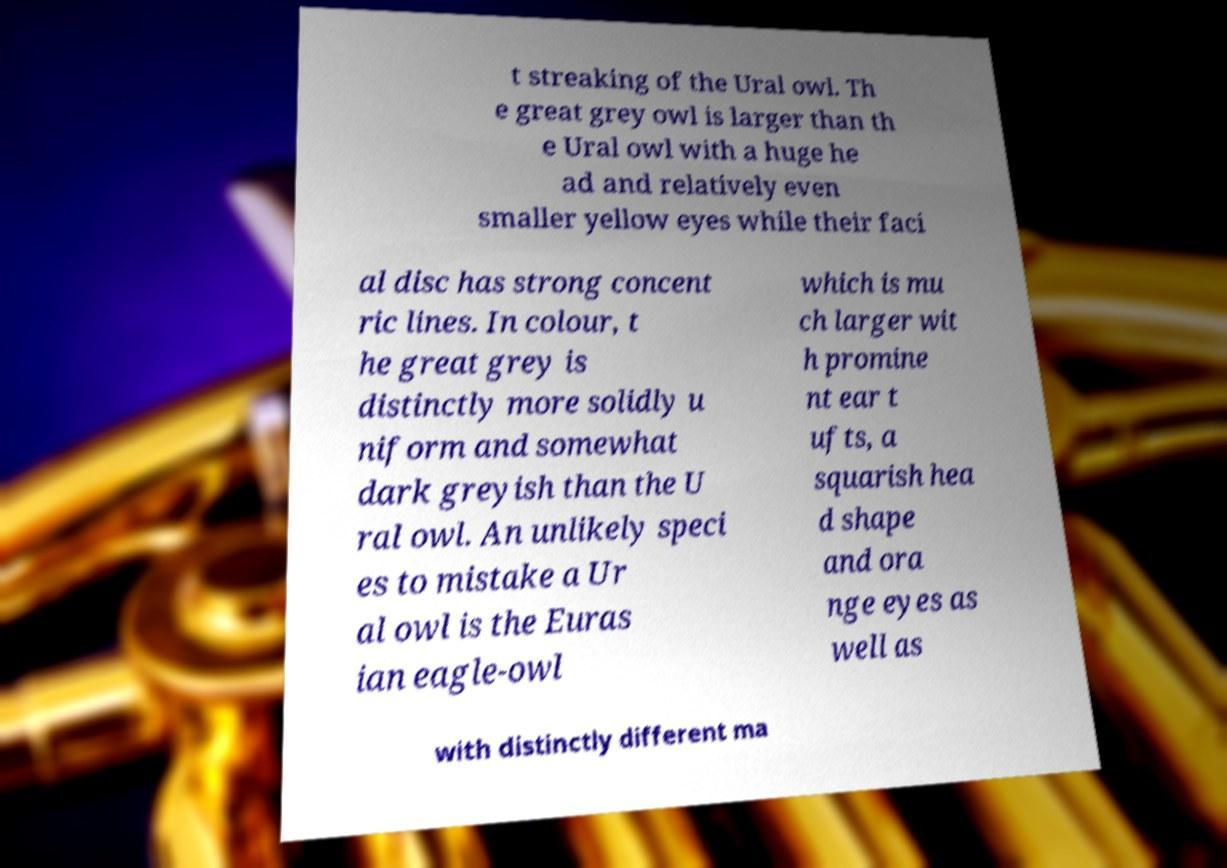Please read and relay the text visible in this image. What does it say? t streaking of the Ural owl. Th e great grey owl is larger than th e Ural owl with a huge he ad and relatively even smaller yellow eyes while their faci al disc has strong concent ric lines. In colour, t he great grey is distinctly more solidly u niform and somewhat dark greyish than the U ral owl. An unlikely speci es to mistake a Ur al owl is the Euras ian eagle-owl which is mu ch larger wit h promine nt ear t ufts, a squarish hea d shape and ora nge eyes as well as with distinctly different ma 